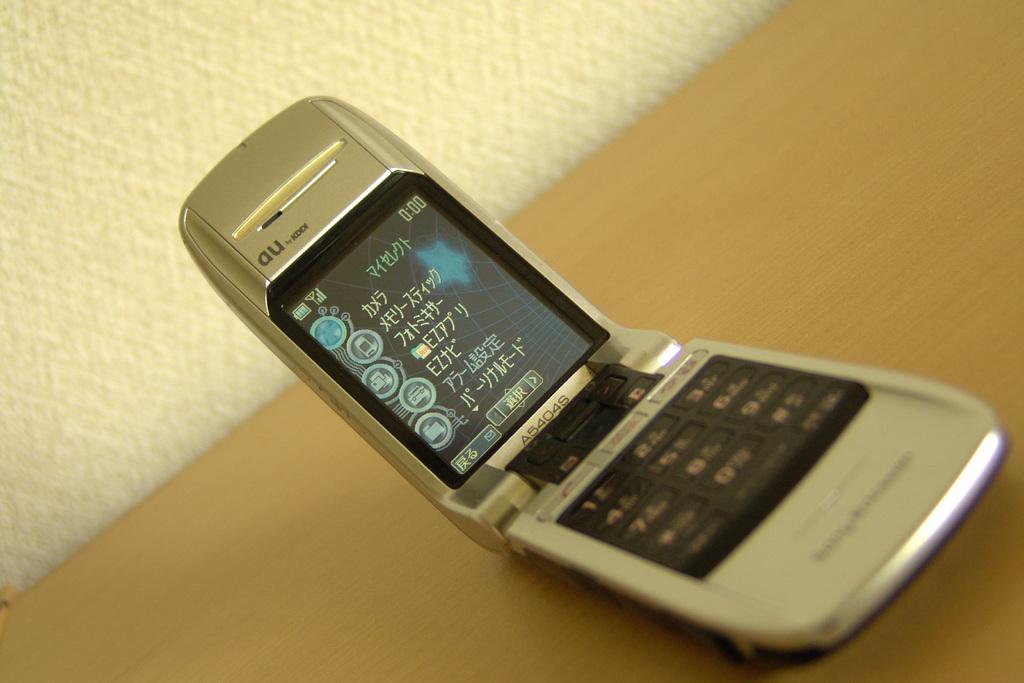This is mobile phone?
Make the answer very short. Yes. 